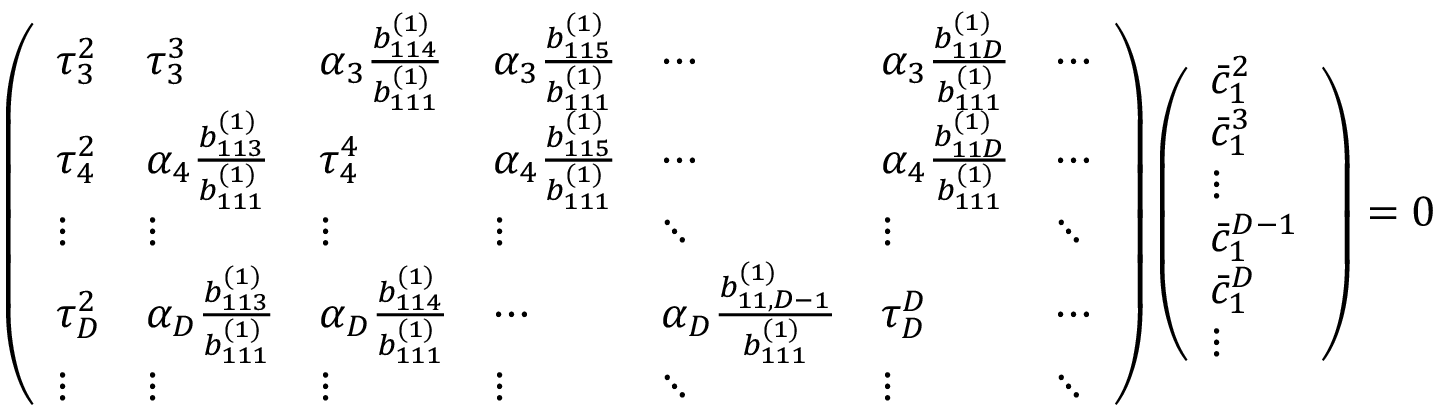<formula> <loc_0><loc_0><loc_500><loc_500>\left ( \begin{array} { l l l l l l l } { \tau _ { 3 } ^ { 2 } } & { \tau _ { 3 } ^ { 3 } } & { \alpha _ { 3 } \frac { b _ { 1 1 4 } ^ { ( 1 ) } } { b _ { 1 1 1 } ^ { ( 1 ) } } } & { \alpha _ { 3 } \frac { b _ { 1 1 5 } ^ { ( 1 ) } } { b _ { 1 1 1 } ^ { ( 1 ) } } } & { \cdots } & { \alpha _ { 3 } \frac { b _ { 1 1 D } ^ { ( 1 ) } } { b _ { 1 1 1 } ^ { ( 1 ) } } } & { \cdots } \\ { \tau _ { 4 } ^ { 2 } } & { \alpha _ { 4 } \frac { b _ { 1 1 3 } ^ { ( 1 ) } } { b _ { 1 1 1 } ^ { ( 1 ) } } } & { \tau _ { 4 } ^ { 4 } } & { \alpha _ { 4 } \frac { b _ { 1 1 5 } ^ { ( 1 ) } } { b _ { 1 1 1 } ^ { ( 1 ) } } } & { \cdots } & { \alpha _ { 4 } \frac { b _ { 1 1 D } ^ { ( 1 ) } } { b _ { 1 1 1 } ^ { ( 1 ) } } } & { \cdots } \\ { \vdots } & { \vdots } & { \vdots } & { \vdots } & { \ddots } & { \vdots } & { \ddots } \\ { \tau _ { D } ^ { 2 } } & { \alpha _ { D } \frac { b _ { 1 1 3 } ^ { ( 1 ) } } { b _ { 1 1 1 } ^ { ( 1 ) } } } & { \alpha _ { D } \frac { b _ { 1 1 4 } ^ { ( 1 ) } } { b _ { 1 1 1 } ^ { ( 1 ) } } } & { \cdots } & { \alpha _ { D } \frac { b _ { 1 1 , D - 1 } ^ { ( 1 ) } } { b _ { 1 1 1 } ^ { ( 1 ) } } } & { \tau _ { D } ^ { D } } & { \cdots } \\ { \vdots } & { \vdots } & { \vdots } & { \vdots } & { \ddots } & { \vdots } & { \ddots } \end{array} \right ) \left ( \begin{array} { l } { \bar { c } _ { 1 } ^ { 2 } } \\ { \bar { c } _ { 1 } ^ { 3 } } \\ { \vdots } \\ { \bar { c } _ { 1 } ^ { D - 1 } } \\ { \bar { c } _ { 1 } ^ { D } } \\ { \vdots } \end{array} \right ) = 0</formula> 